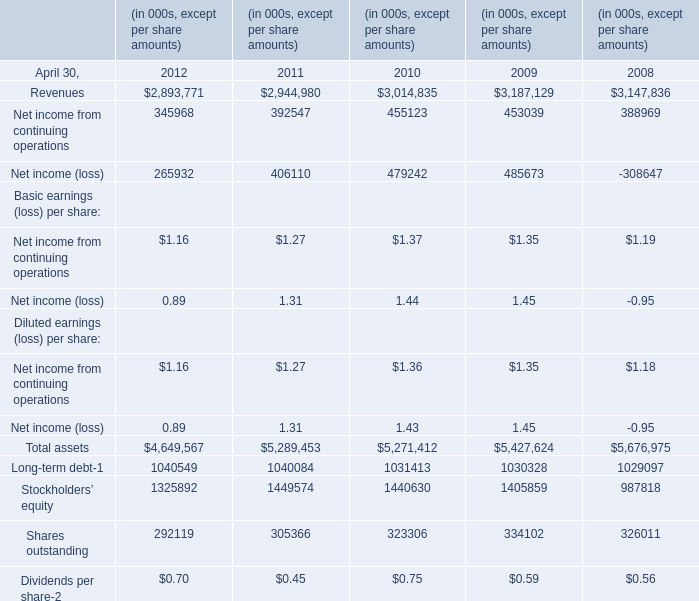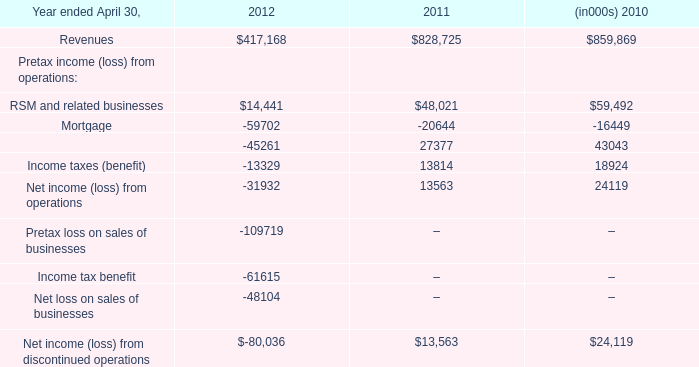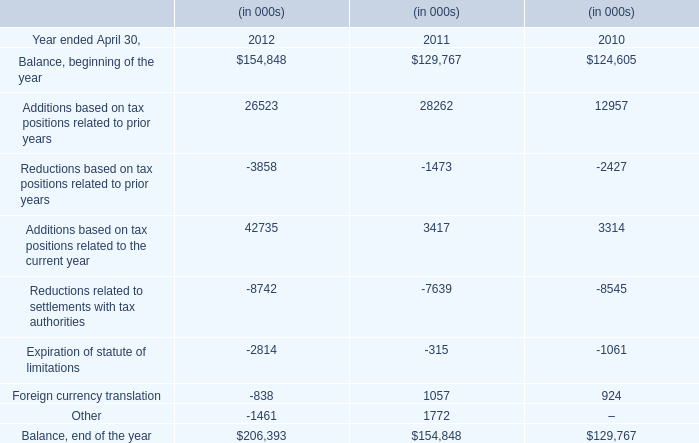What's the increasing rate of Total assets at April 30,2011? 
Computations: ((5289453 - 5271412) / 5271412)
Answer: 0.00342. 